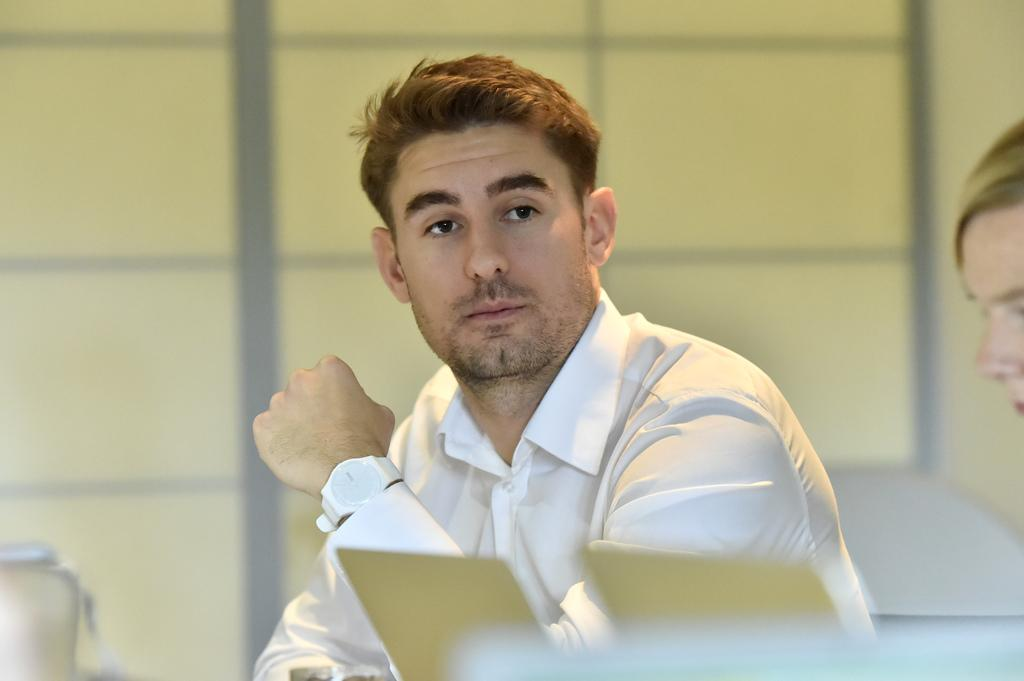How many people are present in the image? There are two people in the image, a man and a woman. What are the genders of the individuals in the image? The man and the woman are present in the image. Can you describe the relationship between the man and the woman in the image? The relationship between the man and the woman is not specified in the image. What type of bread is the woman holding in the image? There is no bread present in the image; it features a man and a woman. How many members are on the team in the image? There is no team present in the image; it features a man and a woman. 